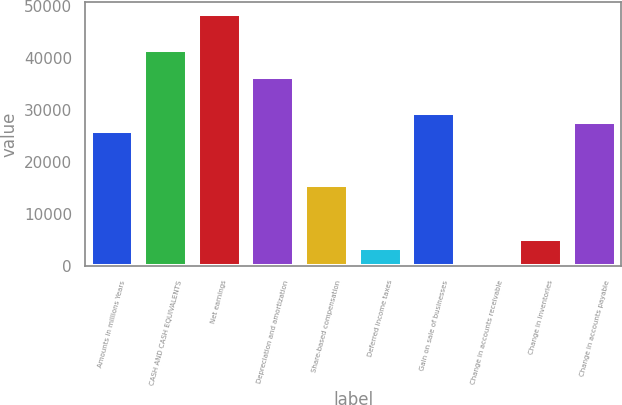<chart> <loc_0><loc_0><loc_500><loc_500><bar_chart><fcel>Amounts in millions Years<fcel>CASH AND CASH EQUIVALENTS<fcel>Net earnings<fcel>Depreciation and amortization<fcel>Share-based compensation<fcel>Deferred income taxes<fcel>Gain on sale of businesses<fcel>Change in accounts receivable<fcel>Change in inventories<fcel>Change in accounts payable<nl><fcel>25964<fcel>41534<fcel>48454<fcel>36344<fcel>15584<fcel>3474<fcel>29424<fcel>14<fcel>5204<fcel>27694<nl></chart> 